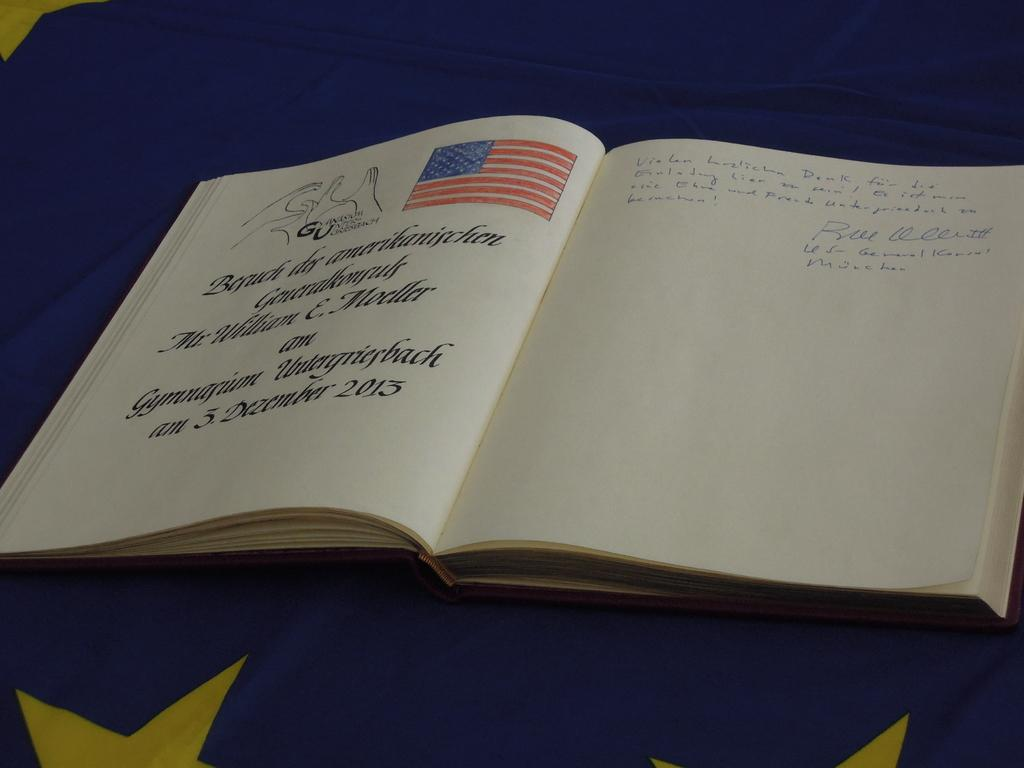<image>
Render a clear and concise summary of the photo. A guest book for an event taking place on December 3, 2013. 